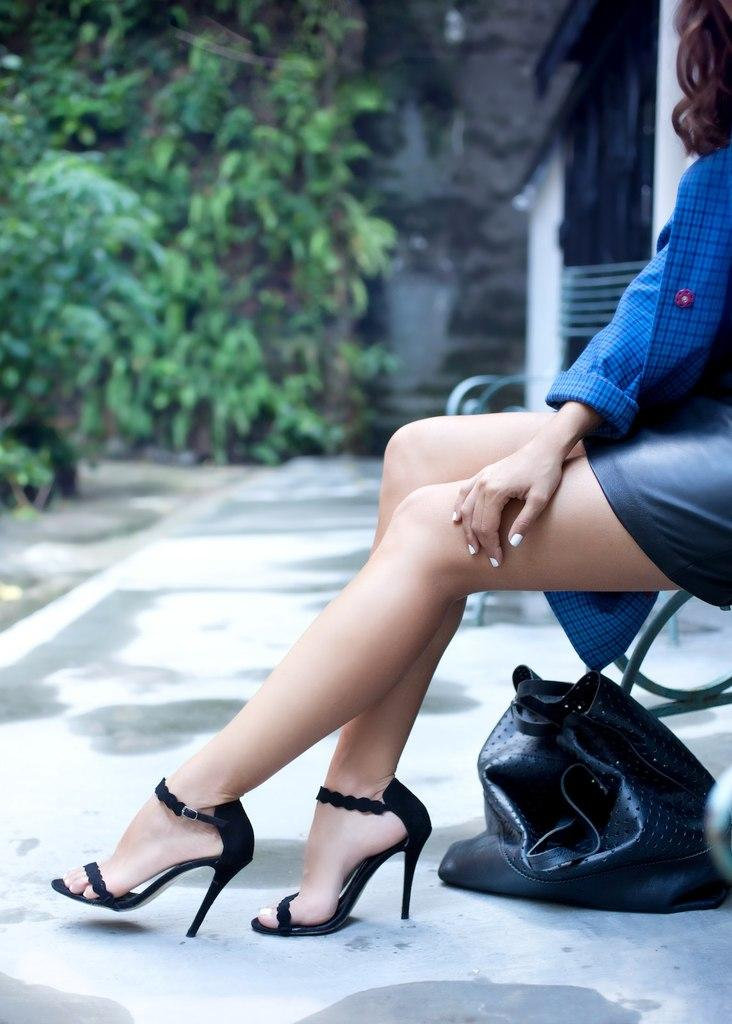What is the lady doing in the image? The lady is sitting on the right side of the image. What is the lady wearing in the image? The lady is wearing a blue dress in the image. What object can be seen on the floor in the image? There is a bag placed on the floor in the image. What can be seen in the background of the image? There are trees in the background of the image. What type of machine is the lady operating in the image? There is no machine present in the image; the lady is simply sitting and wearing a blue dress. 